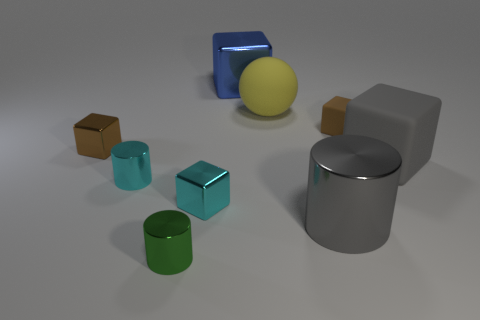Subtract all blue cubes. How many cubes are left? 4 Subtract 2 blocks. How many blocks are left? 3 Subtract all tiny brown matte cubes. How many cubes are left? 4 Subtract all green blocks. Subtract all purple spheres. How many blocks are left? 5 Add 1 tiny red metal blocks. How many objects exist? 10 Subtract all cubes. How many objects are left? 4 Add 1 tiny purple metal things. How many tiny purple metal things exist? 1 Subtract 0 green balls. How many objects are left? 9 Subtract all gray objects. Subtract all small cyan shiny cylinders. How many objects are left? 6 Add 2 green shiny things. How many green shiny things are left? 3 